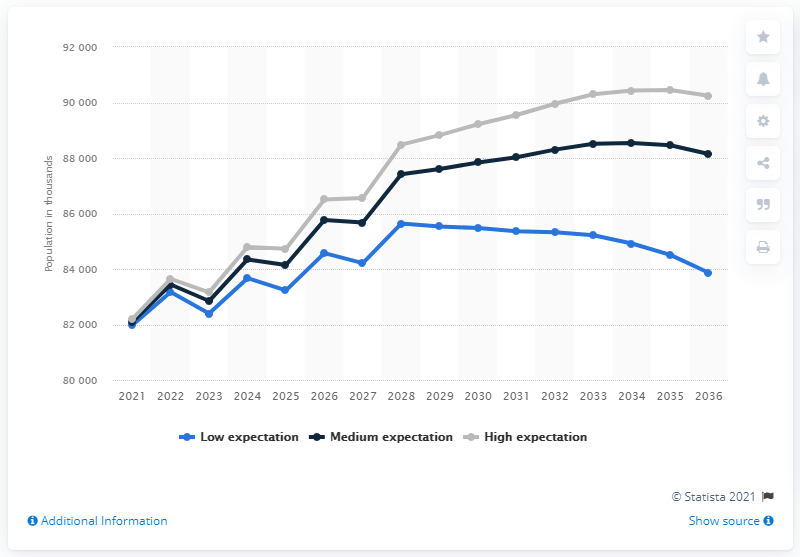Draw attention to some important aspects in this diagram. According to estimates, the Russian working-age population is expected to begin declining in 2034. The study predicted that the decrease in the stock market would begin in 2028, as per the low expectation scenario. 